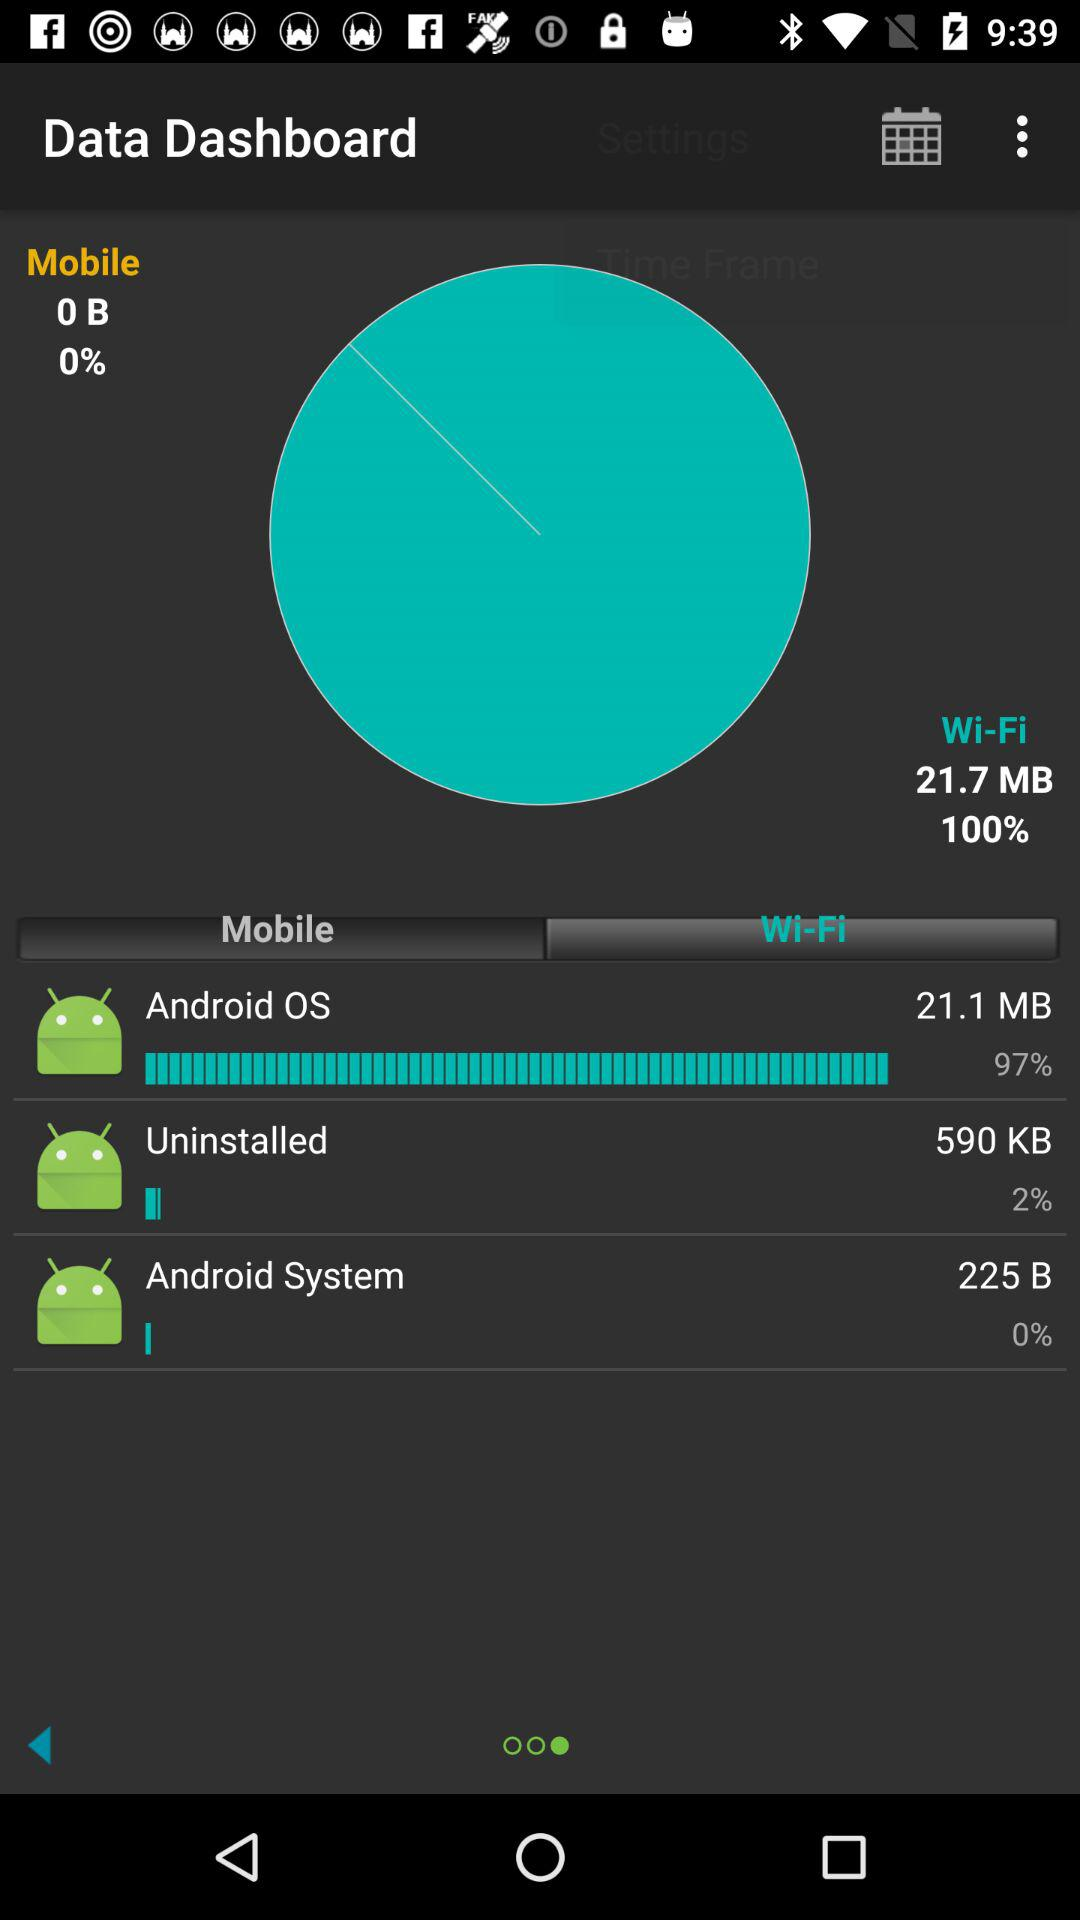How much data is consumed by the Android OS over WiFi in MB? Over WiFi, the Android OS has consumed 21.1 MB of data. 